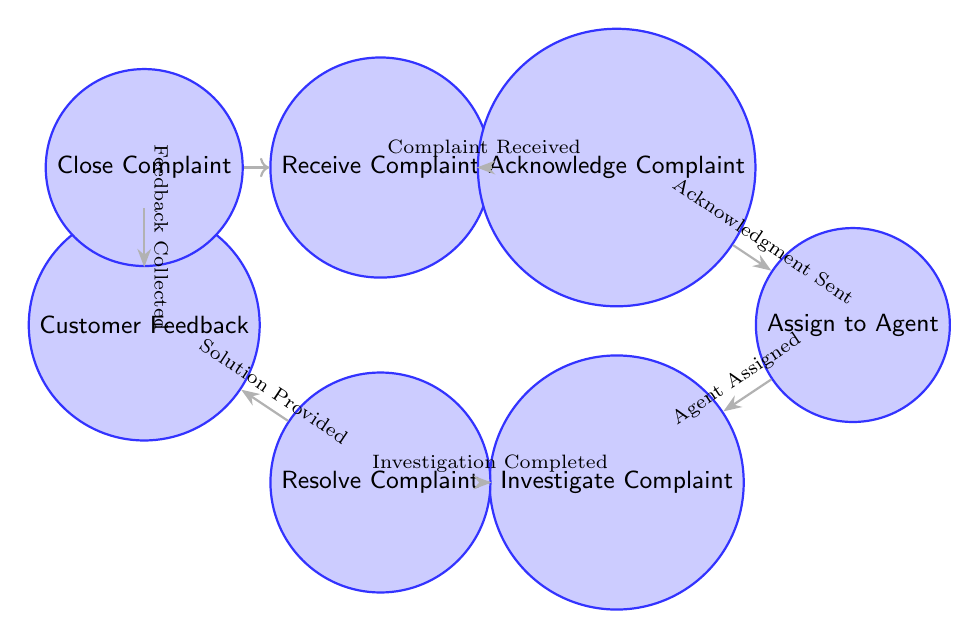What is the initial state of the customer service workflow? The initial state in the diagram is labeled as "Receive Complaint," which is where the customer's complaint is first received.
Answer: Receive Complaint How many states are depicted in the diagram? Counting all the states, there are a total of 7 states which are: Receive Complaint, Acknowledge Complaint, Assign to Agent, Investigate Complaint, Resolve Complaint, Customer Feedback, and Close Complaint.
Answer: 7 What is the action taken after "Acknowledge Complaint"? The action that follows "Acknowledge Complaint" is "Acknowledgment Sent," indicating that the customer has been informed about the acknowledgment of their complaint.
Answer: Acknowledgment Sent Which state directly follows "Investigate Complaint"? The state that comes directly after "Investigate Complaint" is "Resolve Complaint," where the assigned agent provides a solution after completing the investigation.
Answer: Resolve Complaint What is the last action before closing the complaint? The last action before closing the complaint is "Feedback Collected," which occurs after gathering the customer's feedback on the resolution process.
Answer: Feedback Collected Can a complaint be closed without customer feedback? Based on the flow in the diagram, it shows that "Customer Feedback" must occur before "Close Complaint," therefore a complaint cannot be closed without collecting feedback from the customer.
Answer: No What type of diagram is represented by this workflow? The workflow is represented as a Finite State Machine, which consists of states and transitions between those states to depict the flow of the customer service process.
Answer: Finite State Machine Which state does not have any incoming transitions? The state "Receive Complaint" does not have any incoming transitions as it is the starting point where complaints are first received.
Answer: Receive Complaint How many transitions are present in this diagram? There are a total of 6 transitions depicted in the diagram, connecting the different states to describe the flow of the complaint handling process.
Answer: 6 